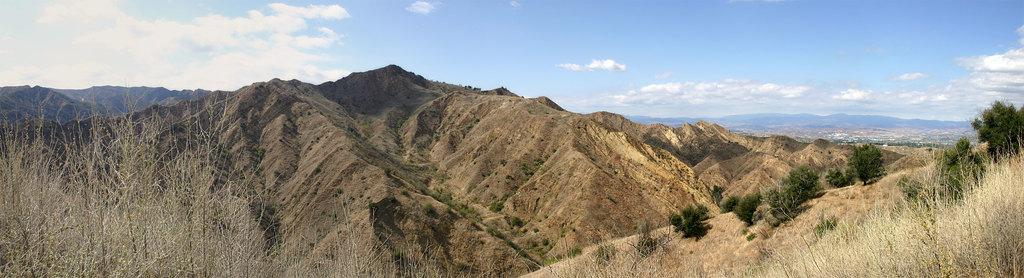What is the main subject of the image? The main subject of the image is a mountain. What can be seen on the mountain in the image? There are trees on the mountains in the image. What is visible at the top of the image? The sky is visible at the top of the image. What can be observed in the sky? Clouds are present in the sky. What type of advertisement can be seen on the mountain in the image? There is no advertisement present in the image. 